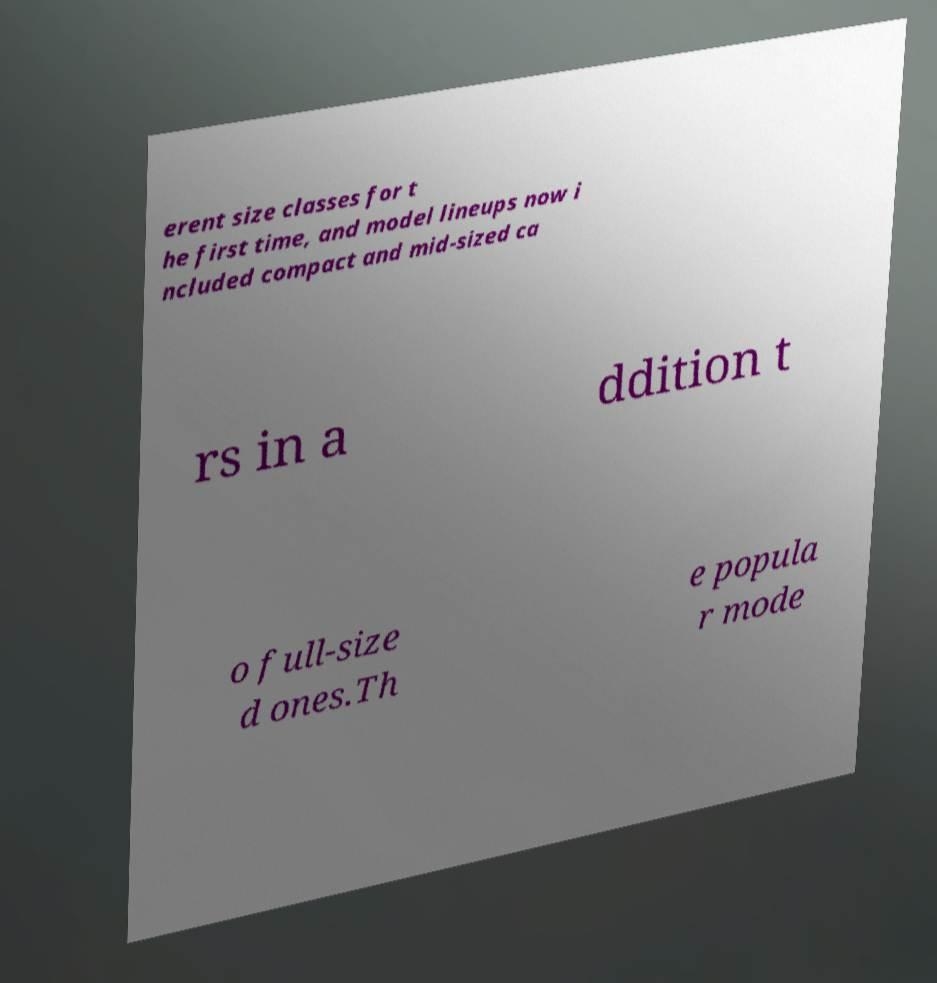For documentation purposes, I need the text within this image transcribed. Could you provide that? erent size classes for t he first time, and model lineups now i ncluded compact and mid-sized ca rs in a ddition t o full-size d ones.Th e popula r mode 